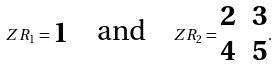Convert formula to latex. <formula><loc_0><loc_0><loc_500><loc_500>Z R _ { 1 } = \begin{matrix} 1 \end{matrix} \quad \text {and} \quad Z R _ { 2 } = \begin{matrix} 2 & 3 \\ 4 & 5 \end{matrix} .</formula> 